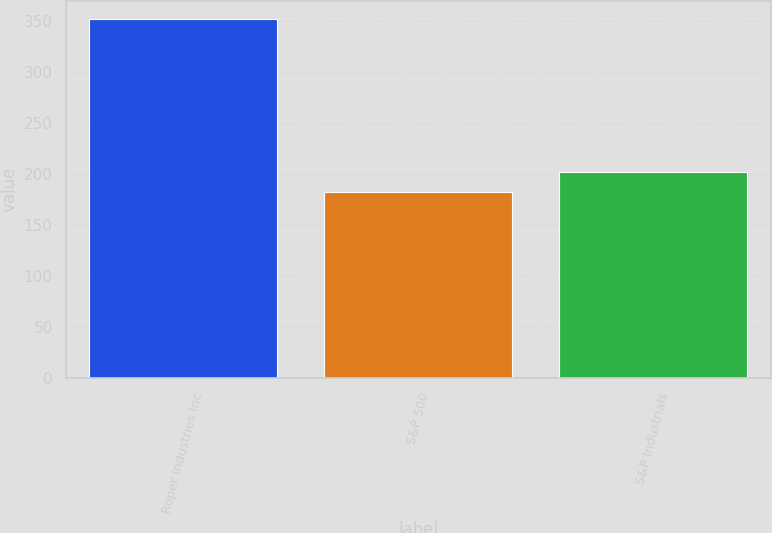Convert chart to OTSL. <chart><loc_0><loc_0><loc_500><loc_500><bar_chart><fcel>Roper Industries Inc<fcel>S&P 500<fcel>S&P Industrials<nl><fcel>352.19<fcel>182.87<fcel>202.64<nl></chart> 